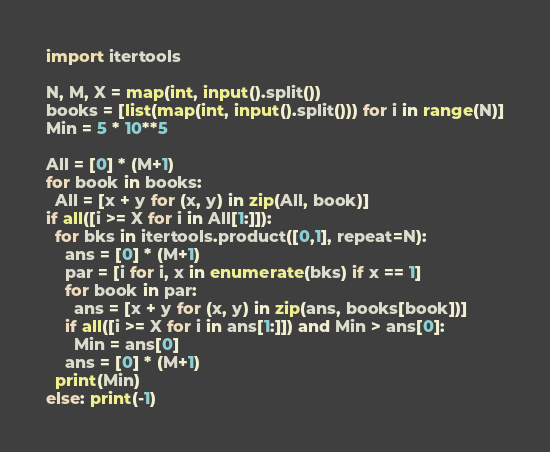Convert code to text. <code><loc_0><loc_0><loc_500><loc_500><_Python_>import itertools

N, M, X = map(int, input().split())
books = [list(map(int, input().split())) for i in range(N)]
Min = 5 * 10**5

All = [0] * (M+1)
for book in books:
  All = [x + y for (x, y) in zip(All, book)]
if all([i >= X for i in All[1:]]):
  for bks in itertools.product([0,1], repeat=N):
    ans = [0] * (M+1)
    par = [i for i, x in enumerate(bks) if x == 1]
    for book in par:
      ans = [x + y for (x, y) in zip(ans, books[book])]
    if all([i >= X for i in ans[1:]]) and Min > ans[0]:
      Min = ans[0]
    ans = [0] * (M+1)
  print(Min)
else: print(-1)


</code> 